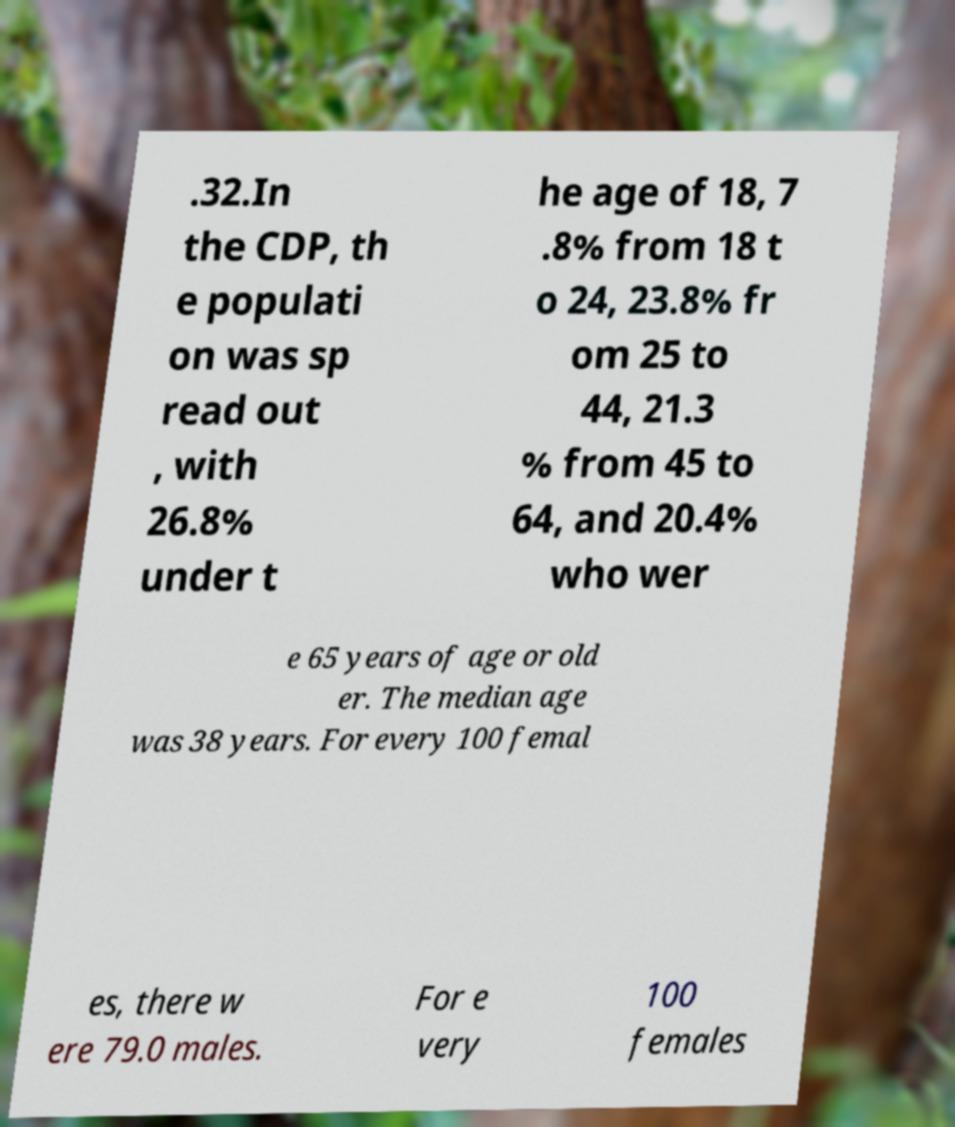Please read and relay the text visible in this image. What does it say? .32.In the CDP, th e populati on was sp read out , with 26.8% under t he age of 18, 7 .8% from 18 t o 24, 23.8% fr om 25 to 44, 21.3 % from 45 to 64, and 20.4% who wer e 65 years of age or old er. The median age was 38 years. For every 100 femal es, there w ere 79.0 males. For e very 100 females 